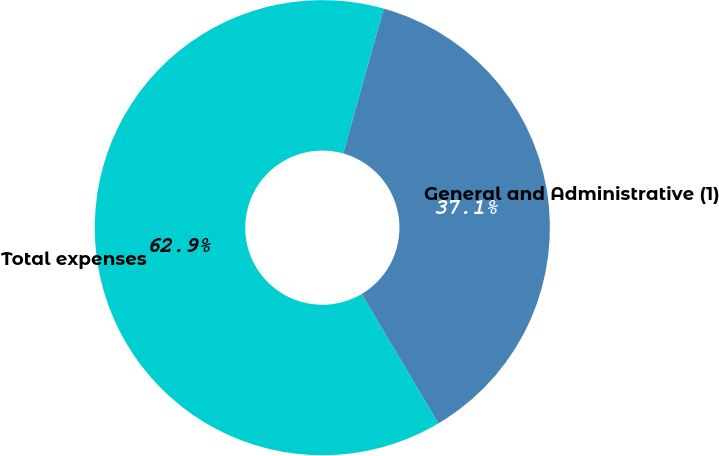<chart> <loc_0><loc_0><loc_500><loc_500><pie_chart><fcel>General and Administrative (1)<fcel>Total expenses<nl><fcel>37.14%<fcel>62.86%<nl></chart> 